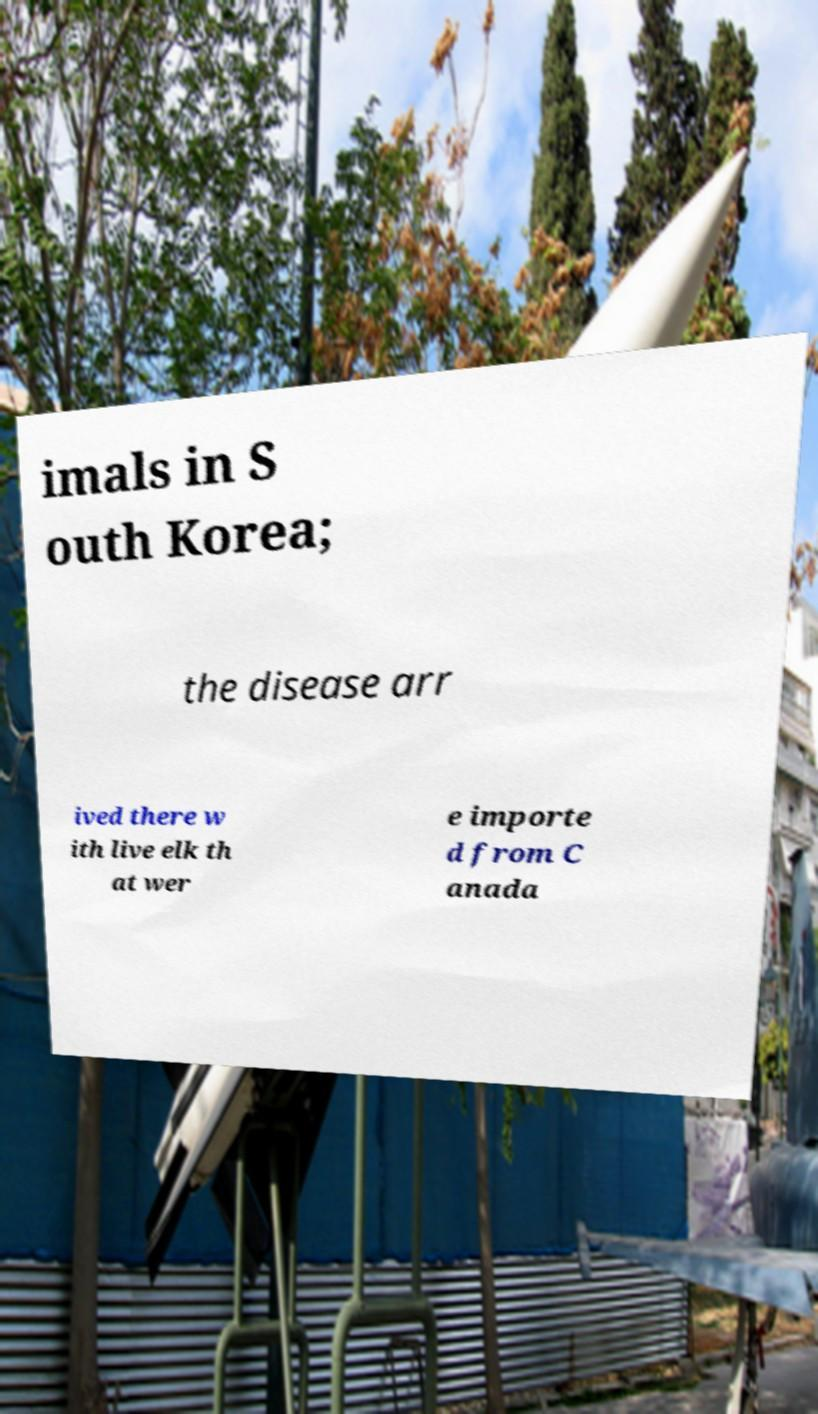Please identify and transcribe the text found in this image. imals in S outh Korea; the disease arr ived there w ith live elk th at wer e importe d from C anada 